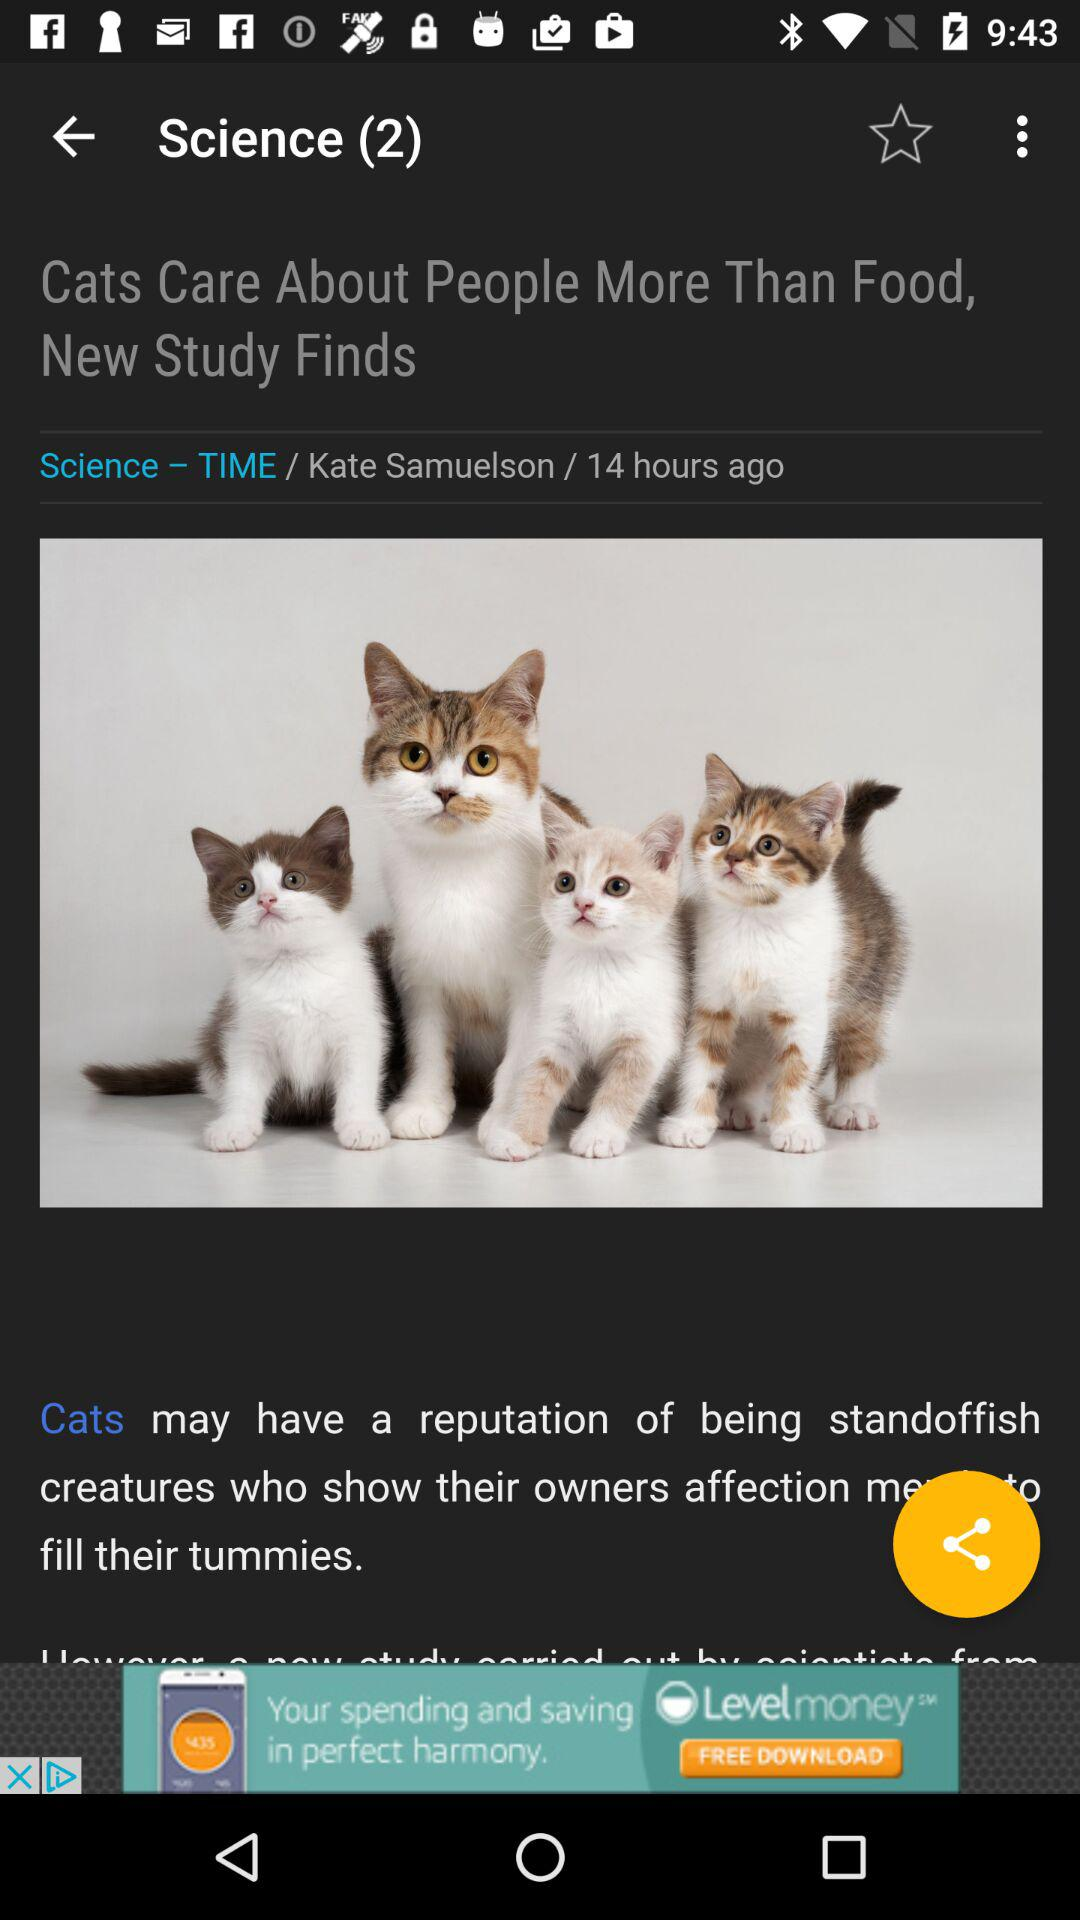What is the topic name given at the top of the screen? The topic name is "Science". 